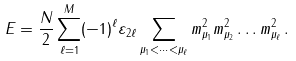Convert formula to latex. <formula><loc_0><loc_0><loc_500><loc_500>E = \frac { N } { 2 } \sum _ { \ell = 1 } ^ { M } ( - 1 ) ^ { \ell } \varepsilon _ { 2 \ell } \sum _ { \mu _ { 1 } < \dots < \mu _ { \ell } } m _ { \mu _ { 1 } } ^ { 2 } m _ { \mu _ { 2 } } ^ { 2 } \dots m _ { \mu _ { \ell } } ^ { 2 } \, .</formula> 